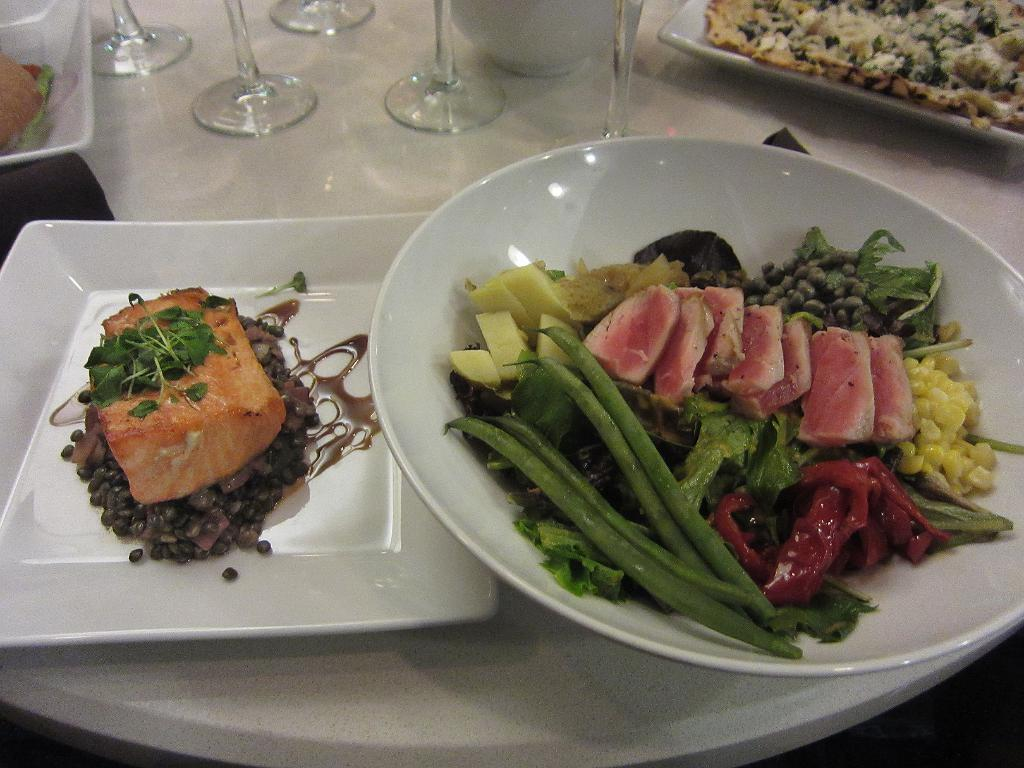What is the main object in the center of the image? There is a table in the center of the image. What items can be seen on the table? There are bowls, plates, glasses, food items, and a few other objects on the table. Can you describe the food items on the table? Unfortunately, the specific food items cannot be determined from the provided facts. What might be used for holding or serving food on the table? Bowls and plates are used for holding or serving food on the table. What type of discovery was made by the sponge in the image? There is no sponge present in the image, and therefore no discovery can be attributed to it. 